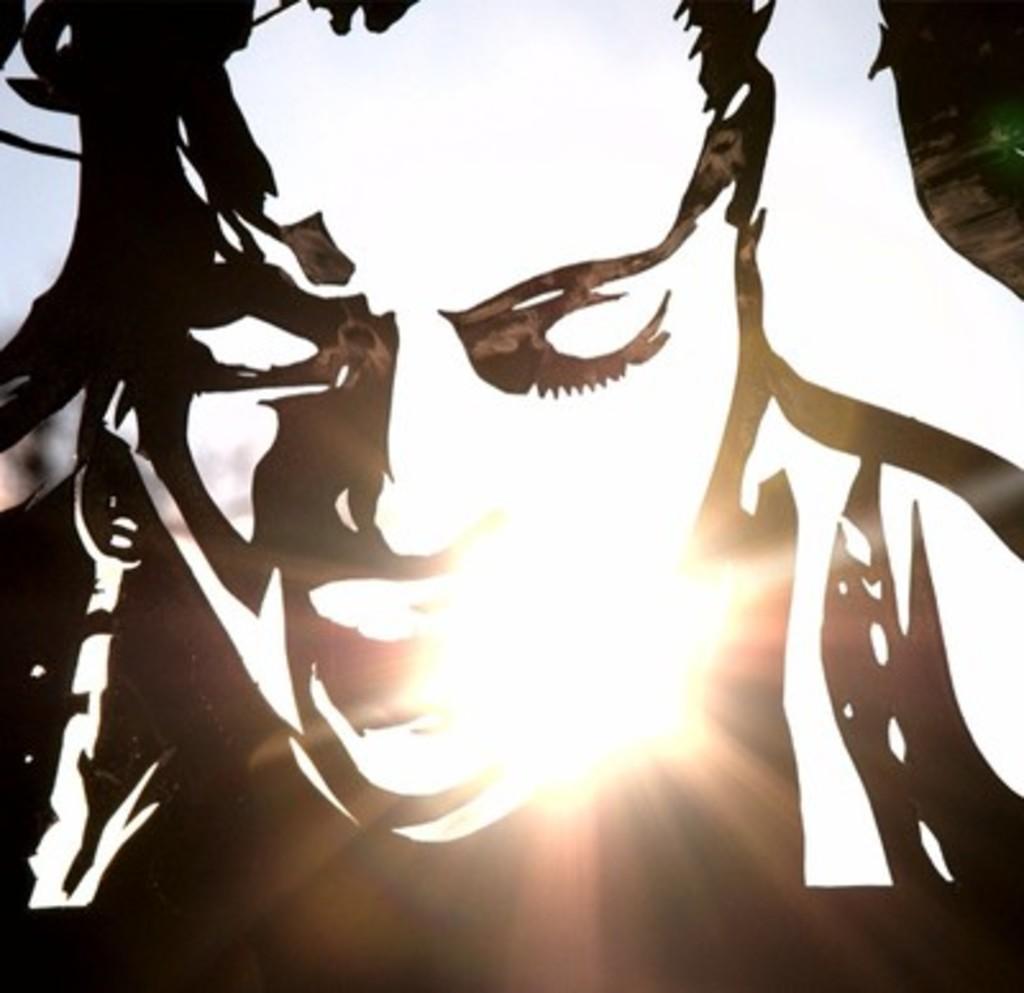Describe this image in one or two sentences. In this image we can see an edited image of a person. 